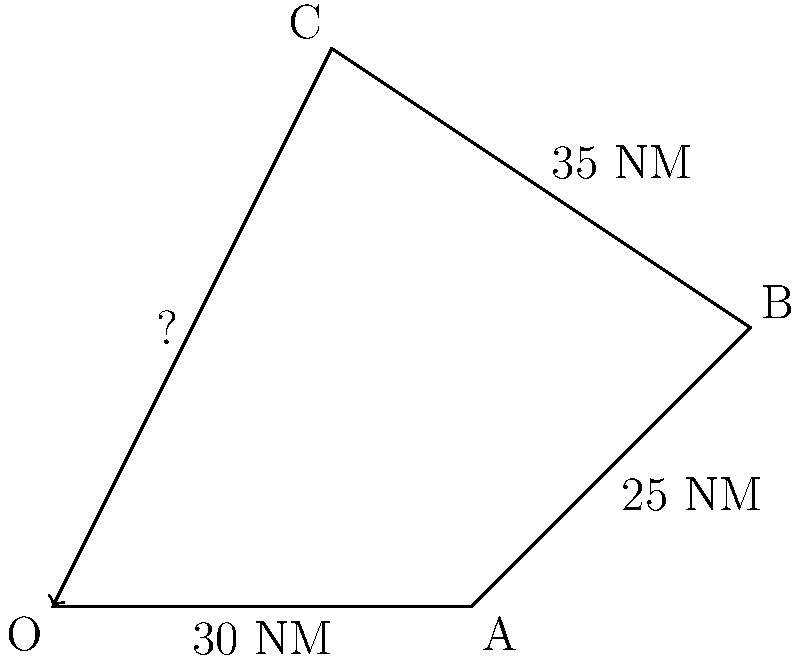You've completed a three-leg sailing trip as shown in the diagram. The first leg was 30 NM due east, the second leg was 25 NM at a bearing of 45°, and the third leg was 35 NM at a bearing of 315°. Using vector addition, calculate the straight-line distance back to your starting point to complete the journey. To solve this problem, we'll use vector addition and the Pythagorean theorem:

1) First, calculate the total displacement in the east-west direction:
   East: $30 + 25 \cos 45° = 30 + 25 \cdot \frac{\sqrt{2}}{2} \approx 47.68$ NM
   West: $35 \cos 45° = 35 \cdot \frac{\sqrt{2}}{2} \approx 24.75$ NM
   Net eastward displacement: $47.68 - 24.75 = 22.93$ NM

2) Next, calculate the total displacement in the north-south direction:
   North: $25 \sin 45° + 35 \sin 45° = (25 + 35) \cdot \frac{\sqrt{2}}{2} \approx 42.43$ NM

3) Now we have the east-west (x) and north-south (y) components of the vector back to the starting point:
   $x = 22.93$ NM (west)
   $y = 42.43$ NM (south)

4) Use the Pythagorean theorem to calculate the straight-line distance:
   Distance = $\sqrt{x^2 + y^2} = \sqrt{22.93^2 + 42.43^2} \approx 48.23$ NM

Therefore, the straight-line distance back to the starting point is approximately 48.23 NM.
Answer: 48.23 NM 